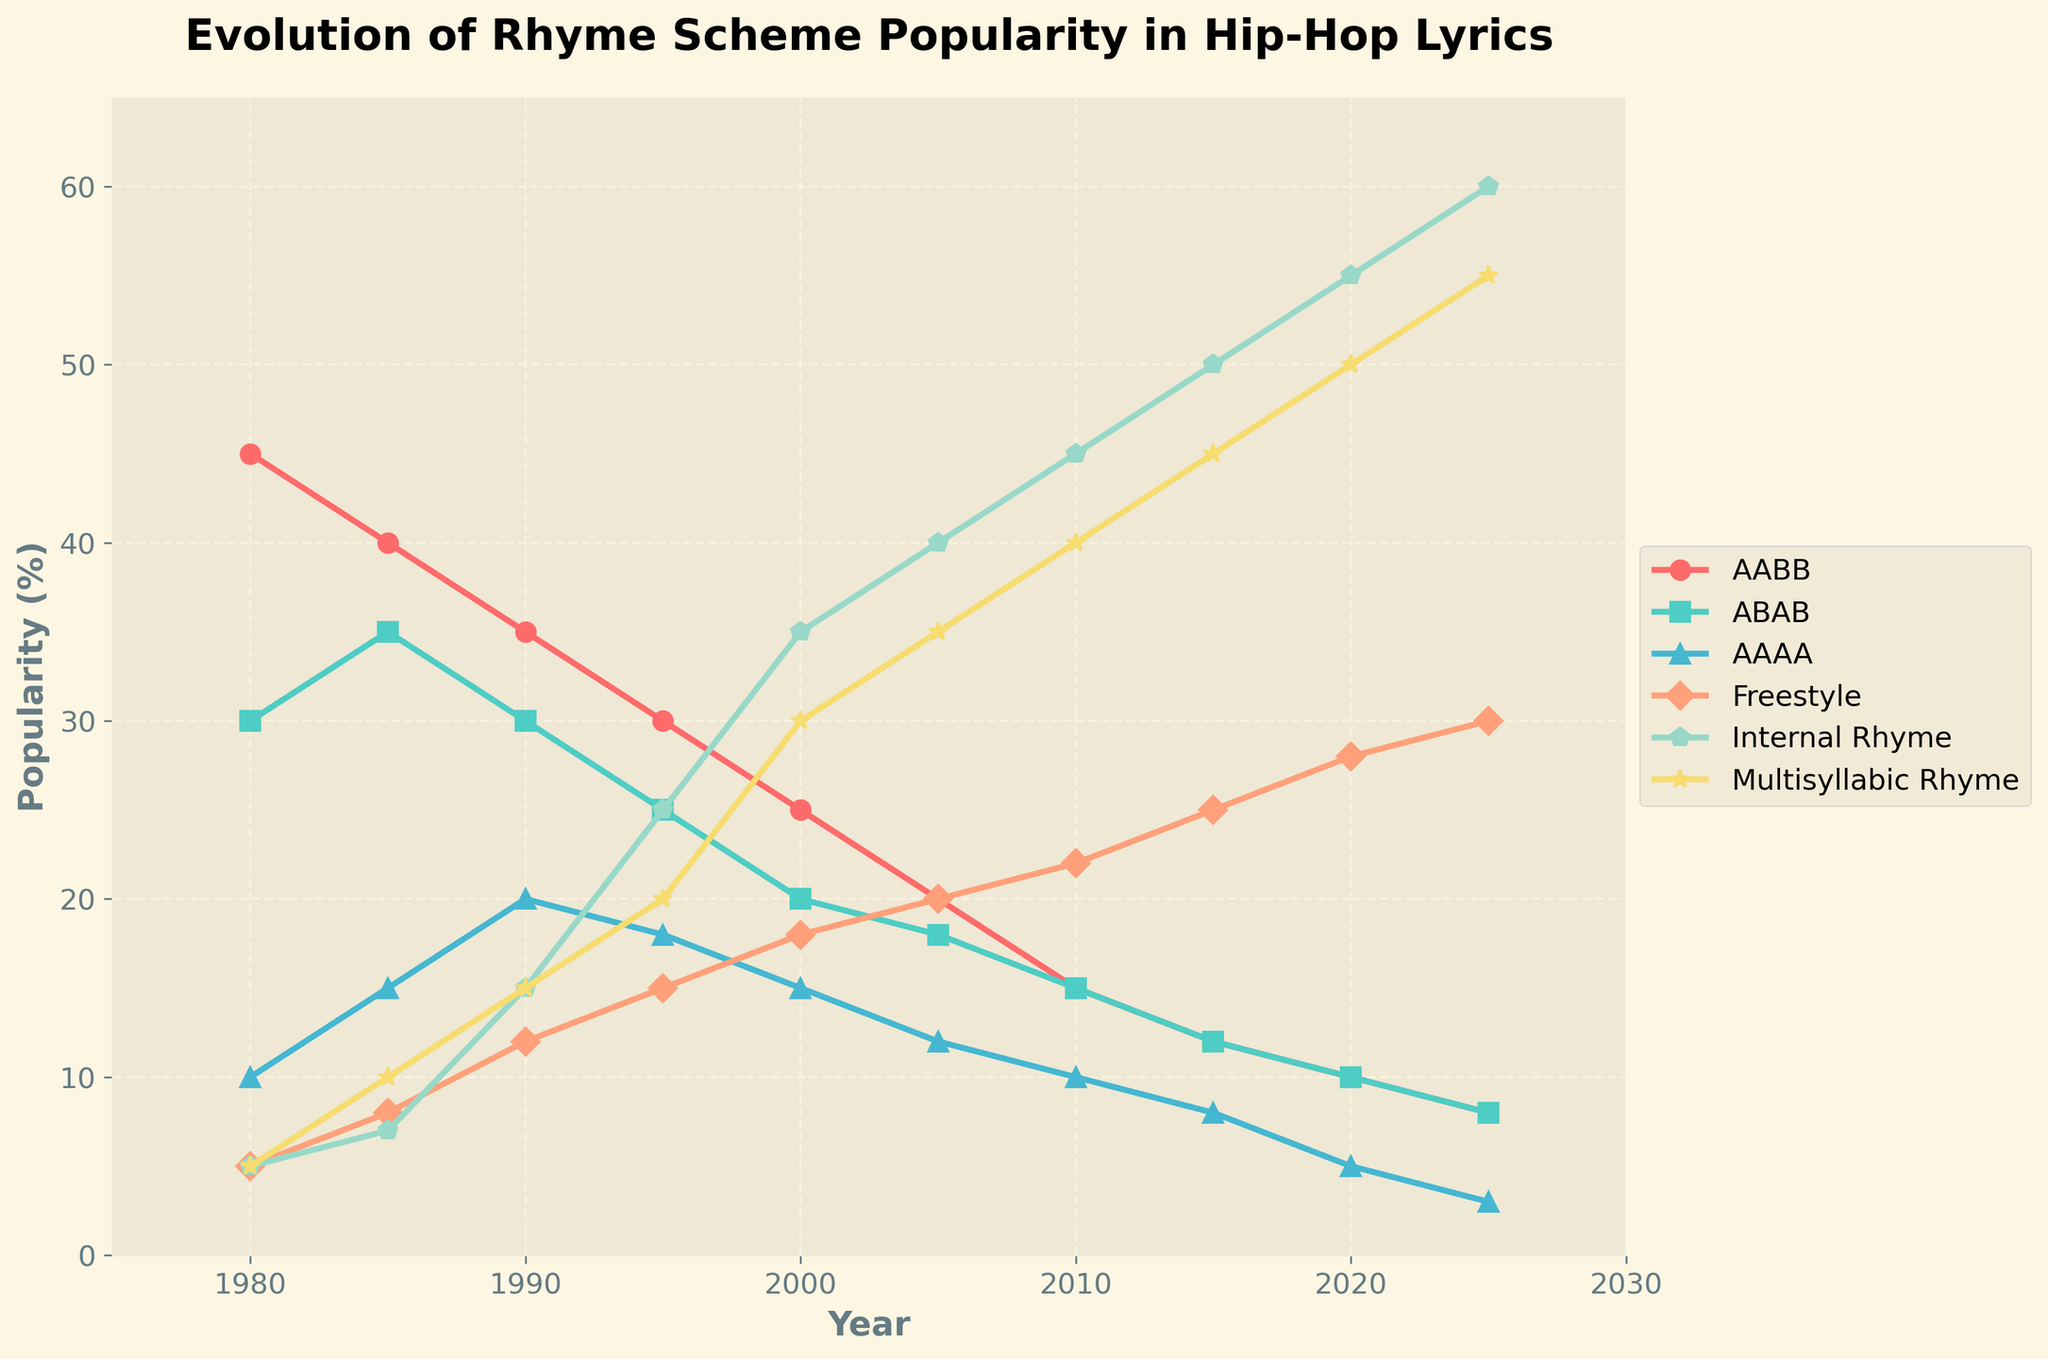Which rhyme scheme has the highest popularity in 2020? Look at the 2020 data points and compare the values for all rhyme schemes. Internal Rhyme has the highest value at 55%.
Answer: Internal Rhyme How did the popularity of the AABB rhyme scheme change from 1980 to 2020? Subtract the 2020 value (10%) from the 1980 value (45%). (45% - 10% = 35%). The popularity decreased by 35 percentage points.
Answer: Decreased by 35% What's the total percentage of popularity for Freestyle rhyme scheme from 1980 to 2025? Sum the values for the Freestyle line across all years. (5+8+12+15+18+20+22+25+28+30 = 183). The total percentage is 183%.
Answer: 183% Between 2000 and 2020, which rhyme scheme saw the steadiest increase in popularity? Look at the trend lines between 2000 and 2020. The Internal Rhyme line consistently rises from 35% to 55% without any dips.
Answer: Internal Rhyme In 2025, which rhyme schemes have equal popularity, and what is their value? Observe the 2025 data points and compare values. AABB and ABAB both have a value of 8%.
Answer: AABB and ABAB, 8% What's the average popularity of ABAB rhyme scheme from 1980 to 2025? Add the values for ABAB from 1980 to 2025 and divide by the number of years (30+35+30+25+20+18+15+12+10+8 = 203, 203/10 = 20.3)
Answer: 20.3% In which decade did Multisyllabic Rhyme see the most significant increase? Compare the changes in value across decades. From 1990 to 2000, the value increased by 15 percentage points (15% to 30%).
Answer: 1990 to 2000 By how many percentage points did the popularity of the AAAA rhyme scheme decrease between 1980 and 2025? Subtract the 2025 value (3%) from the 1980 value (10%). (10% - 3% = 7%). The popularity decreased by 7 percentage points.
Answer: Decreased by 7 percentage points What's the difference in the popularity of Freestyle and Multisyllabic Rhyme in 1995? Look at the 1995 data points for both rhyme schemes and subtract the Freestyle value (15%) from the Multisyllabic Rhyme value (20%). (20% - 15% = 5%).
Answer: 5% Which rhyme scheme has the lowest average popularity over the entire period from 1980 to 2025? Calculate the average for each rhyme scheme and compare. AAAA has the lowest averages (10+15+20+18+15+12+10+8+5+3 = 116, 116/10 = 11.6).
Answer: AAAA 